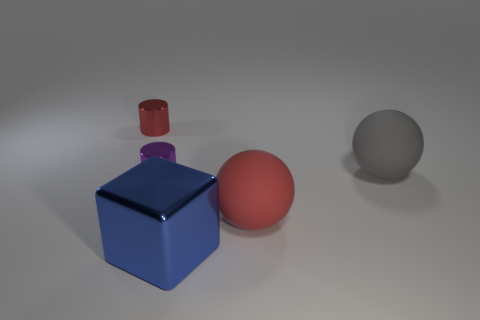Add 4 cyan metal cylinders. How many objects exist? 9 Subtract all balls. How many objects are left? 3 Subtract 1 red cylinders. How many objects are left? 4 Subtract all gray matte spheres. Subtract all small gray cylinders. How many objects are left? 4 Add 1 big rubber objects. How many big rubber objects are left? 3 Add 4 blue metal objects. How many blue metal objects exist? 5 